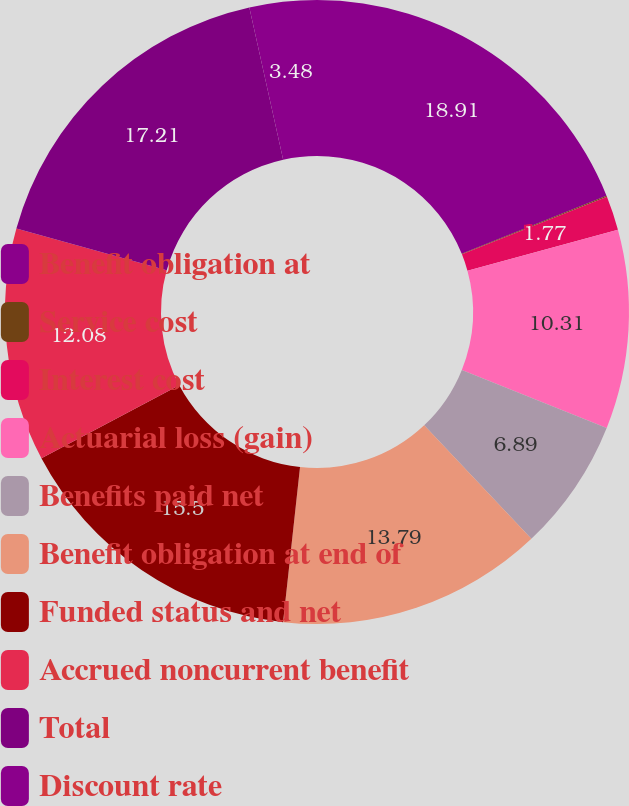Convert chart to OTSL. <chart><loc_0><loc_0><loc_500><loc_500><pie_chart><fcel>Benefit obligation at<fcel>Service cost<fcel>Interest cost<fcel>Actuarial loss (gain)<fcel>Benefits paid net<fcel>Benefit obligation at end of<fcel>Funded status and net<fcel>Accrued noncurrent benefit<fcel>Total<fcel>Discount rate<nl><fcel>18.92%<fcel>0.06%<fcel>1.77%<fcel>10.31%<fcel>6.89%<fcel>13.79%<fcel>15.5%<fcel>12.08%<fcel>17.21%<fcel>3.48%<nl></chart> 